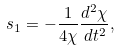<formula> <loc_0><loc_0><loc_500><loc_500>s _ { 1 } = - \frac { 1 } { 4 \chi } \frac { d ^ { 2 } \chi } { d t ^ { 2 } } ,</formula> 